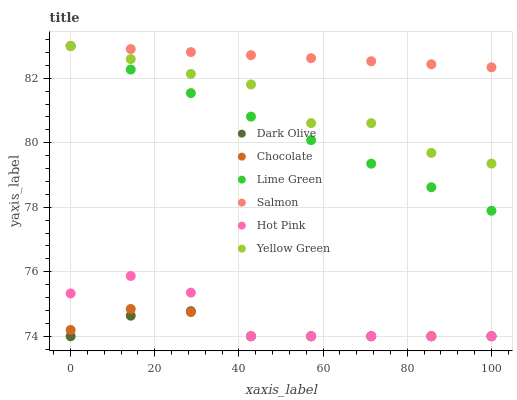Does Dark Olive have the minimum area under the curve?
Answer yes or no. Yes. Does Salmon have the maximum area under the curve?
Answer yes or no. Yes. Does Yellow Green have the minimum area under the curve?
Answer yes or no. No. Does Yellow Green have the maximum area under the curve?
Answer yes or no. No. Is Salmon the smoothest?
Answer yes or no. Yes. Is Yellow Green the roughest?
Answer yes or no. Yes. Is Hot Pink the smoothest?
Answer yes or no. No. Is Hot Pink the roughest?
Answer yes or no. No. Does Dark Olive have the lowest value?
Answer yes or no. Yes. Does Yellow Green have the lowest value?
Answer yes or no. No. Does Lime Green have the highest value?
Answer yes or no. Yes. Does Hot Pink have the highest value?
Answer yes or no. No. Is Dark Olive less than Lime Green?
Answer yes or no. Yes. Is Salmon greater than Chocolate?
Answer yes or no. Yes. Does Chocolate intersect Hot Pink?
Answer yes or no. Yes. Is Chocolate less than Hot Pink?
Answer yes or no. No. Is Chocolate greater than Hot Pink?
Answer yes or no. No. Does Dark Olive intersect Lime Green?
Answer yes or no. No. 